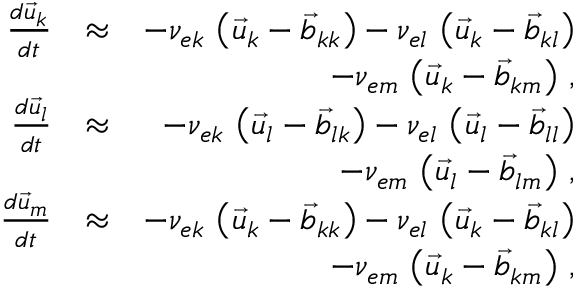<formula> <loc_0><loc_0><loc_500><loc_500>\begin{array} { r l r } { \frac { d \vec { u } _ { k } } { d t } } & { \approx } & { - \nu _ { e k } \, \left ( \vec { u } _ { k } - \vec { b } _ { k k } \right ) - \nu _ { e l } \, \left ( \vec { u } _ { k } - \vec { b } _ { k l } \right ) } \\ & { - \nu _ { e m } \, \left ( \vec { u } _ { k } - \vec { b } _ { k m } \right ) \, , } \\ { \frac { d \vec { u } _ { l } } { d t } } & { \approx } & { - \nu _ { e k } \, \left ( \vec { u } _ { l } - \vec { b } _ { l k } \right ) - \nu _ { e l } \, \left ( \vec { u } _ { l } - \vec { b } _ { l l } \right ) } \\ & { - \nu _ { e m } \, \left ( \vec { u } _ { l } - \vec { b } _ { l m } \right ) \, , } \\ { \frac { d \vec { u } _ { m } } { d t } } & { \approx } & { - \nu _ { e k } \, \left ( \vec { u } _ { k } - \vec { b } _ { k k } \right ) - \nu _ { e l } \, \left ( \vec { u } _ { k } - \vec { b } _ { k l } \right ) } \\ & { - \nu _ { e m } \, \left ( \vec { u } _ { k } - \vec { b } _ { k m } \right ) \, , } \end{array}</formula> 